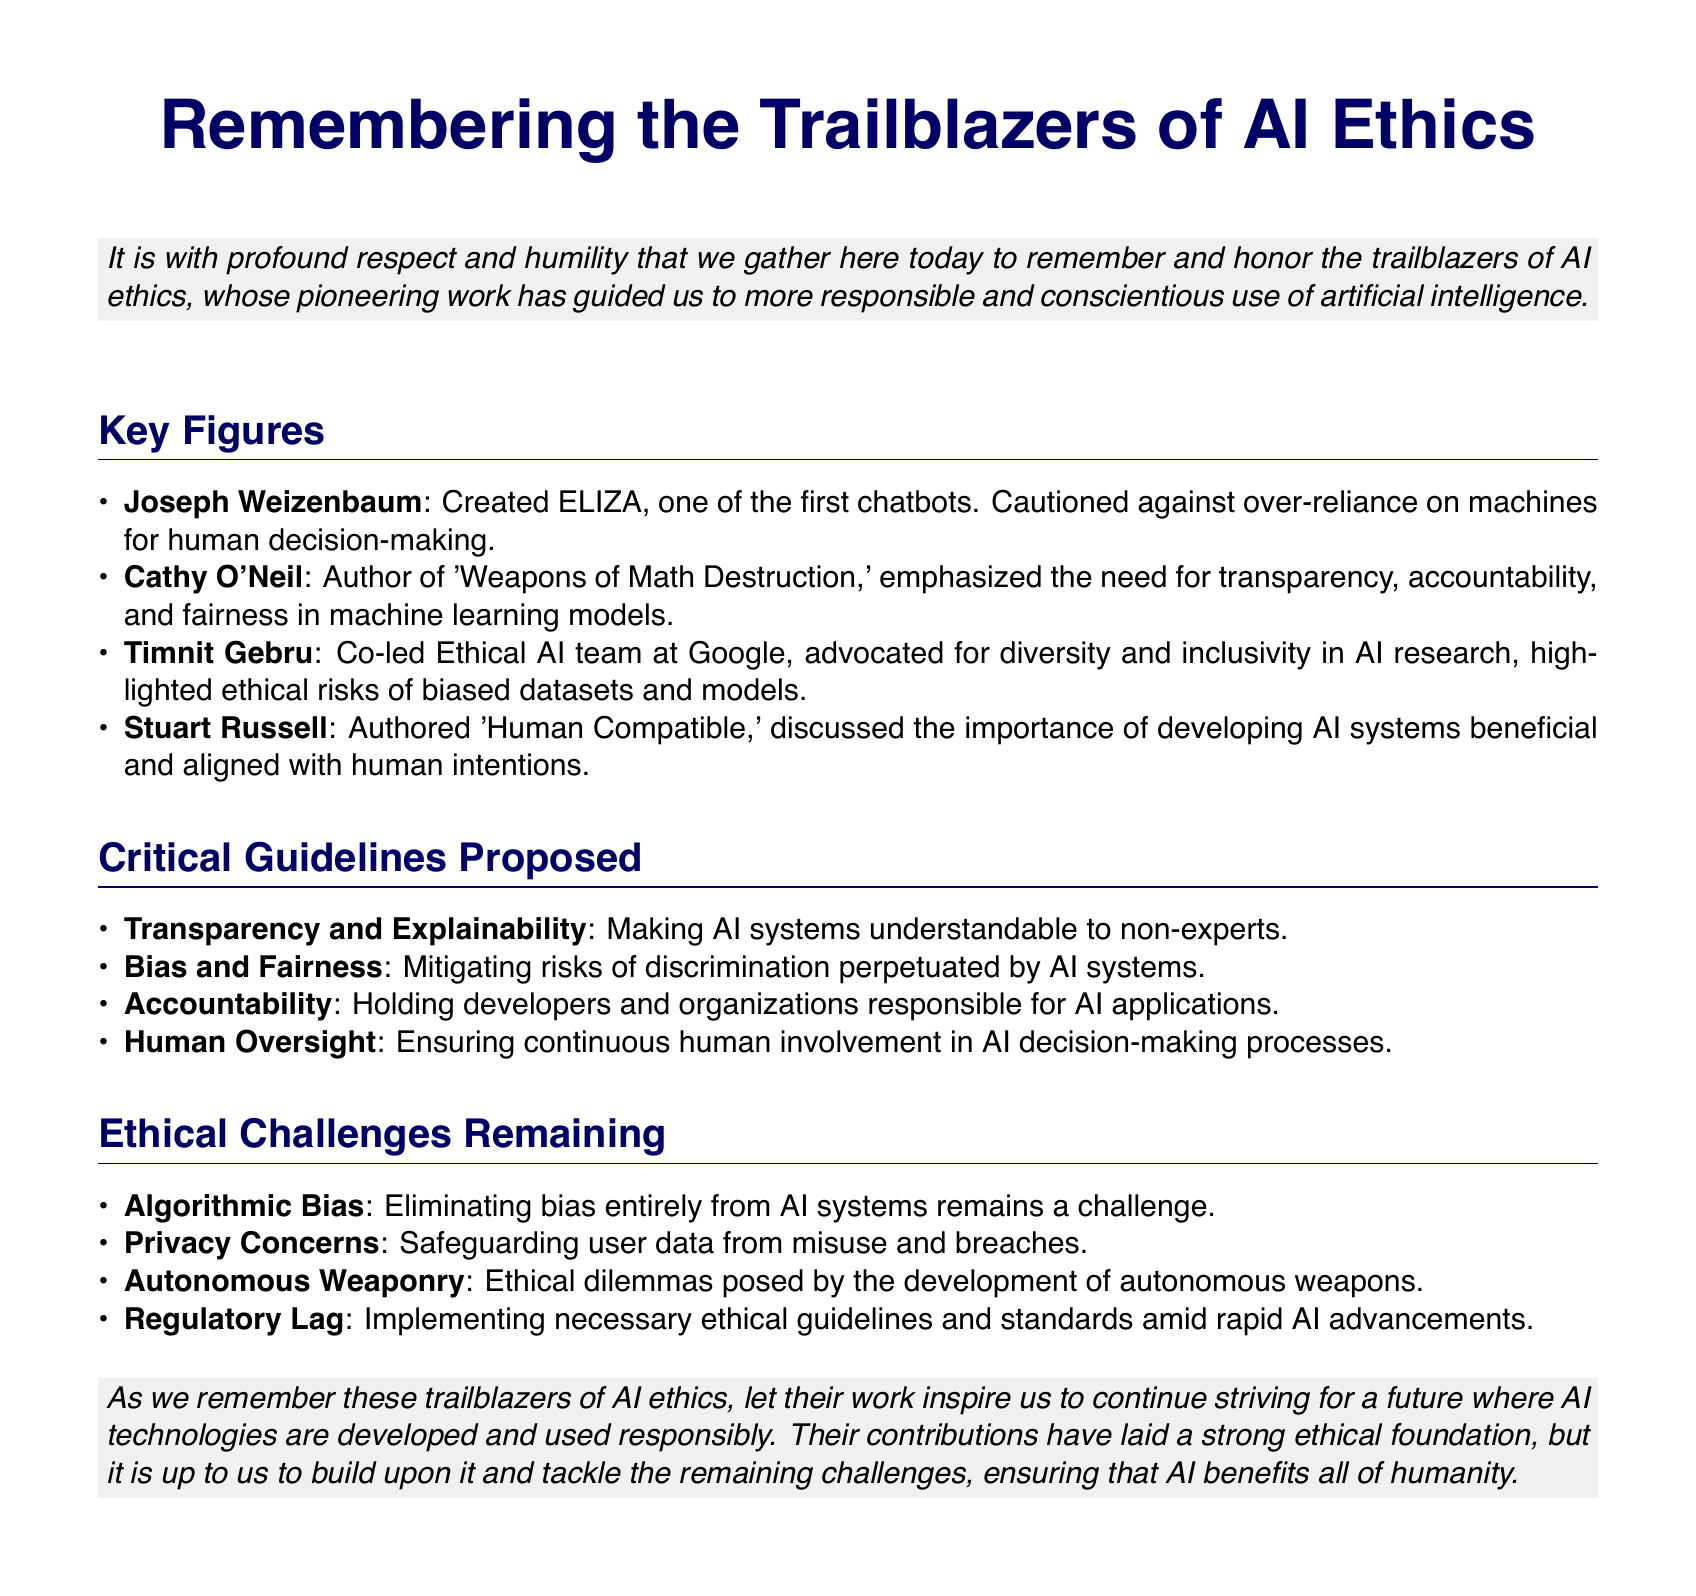What is the title of the document? The title is clearly stated at the top of the document.
Answer: Remembering the Trailblazers of AI Ethics Who created ELIZA? The document specifies the individual known for developing ELIZA, one of the first chatbots.
Answer: Joseph Weizenbaum What did Cathy O'Neil emphasize? The document outlines the main focus of Cathy O'Neil's work in AI ethics.
Answer: Transparency, accountability, and fairness What is one critical guideline proposed for AI systems? The document lists multiple guidelines, so a specific one can be referenced.
Answer: Transparency and Explainability What ethical challenge involves safeguarding user data? The document mentions several challenges, including the one related to user data protection.
Answer: Privacy Concerns How many key figures are mentioned in the document? The document provides a list of individuals recognized for their contributions to AI ethics.
Answer: Four What book did Stuart Russell author? The document identifies the title of a significant work by Stuart Russell.
Answer: Human Compatible What is a remaining ethical challenge regarding AI systems? The document describes various challenges that persist in the field of AI ethics.
Answer: Algorithmic Bias What is the main aim of remembering the trailblazers of AI ethics? The document concludes with the purpose of honoring these figures and their contributions.
Answer: Inspire responsible AI usage 